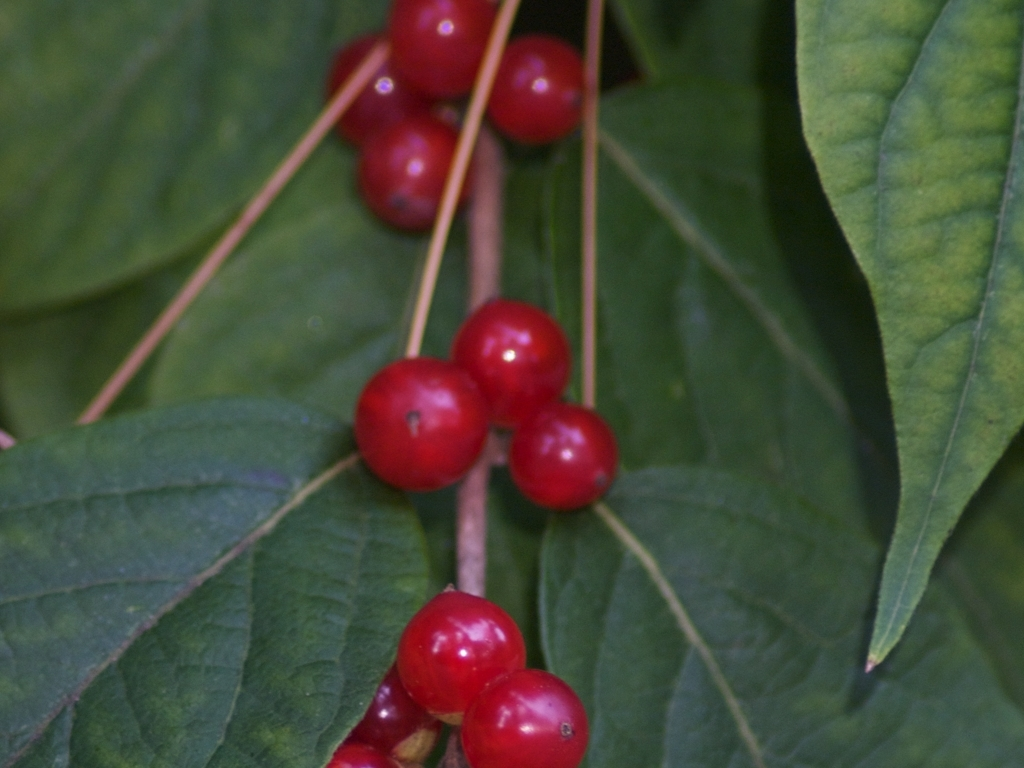Is there any visible noise in the image?
A. Yes
B. No
Answer with the option's letter from the given choices directly.
 B. 